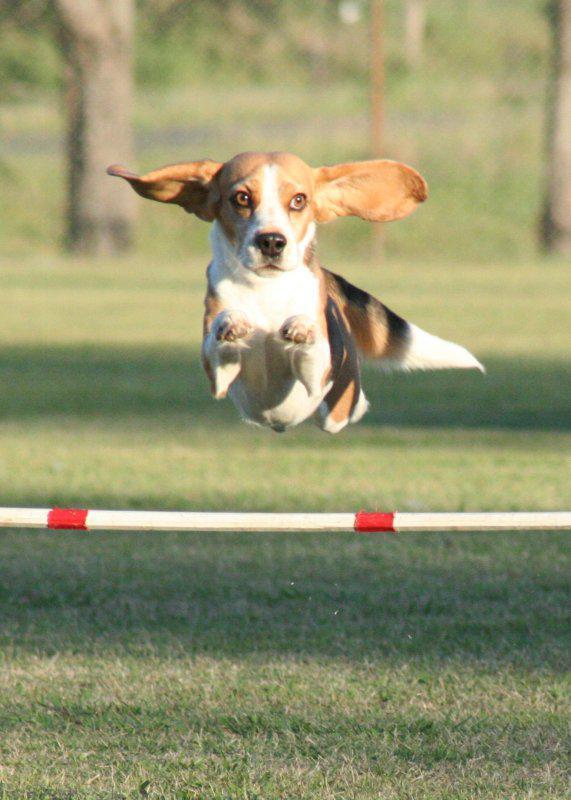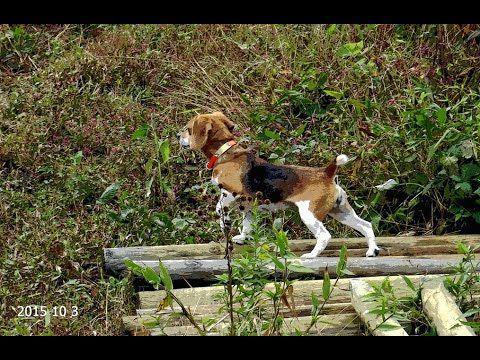The first image is the image on the left, the second image is the image on the right. Assess this claim about the two images: "dogs have ears flapping while they run". Correct or not? Answer yes or no. Yes. The first image is the image on the left, the second image is the image on the right. Considering the images on both sides, is "At least one of the dogs in one of the images has a horizontal or vertical ear position that is not flopped downwards." valid? Answer yes or no. Yes. 